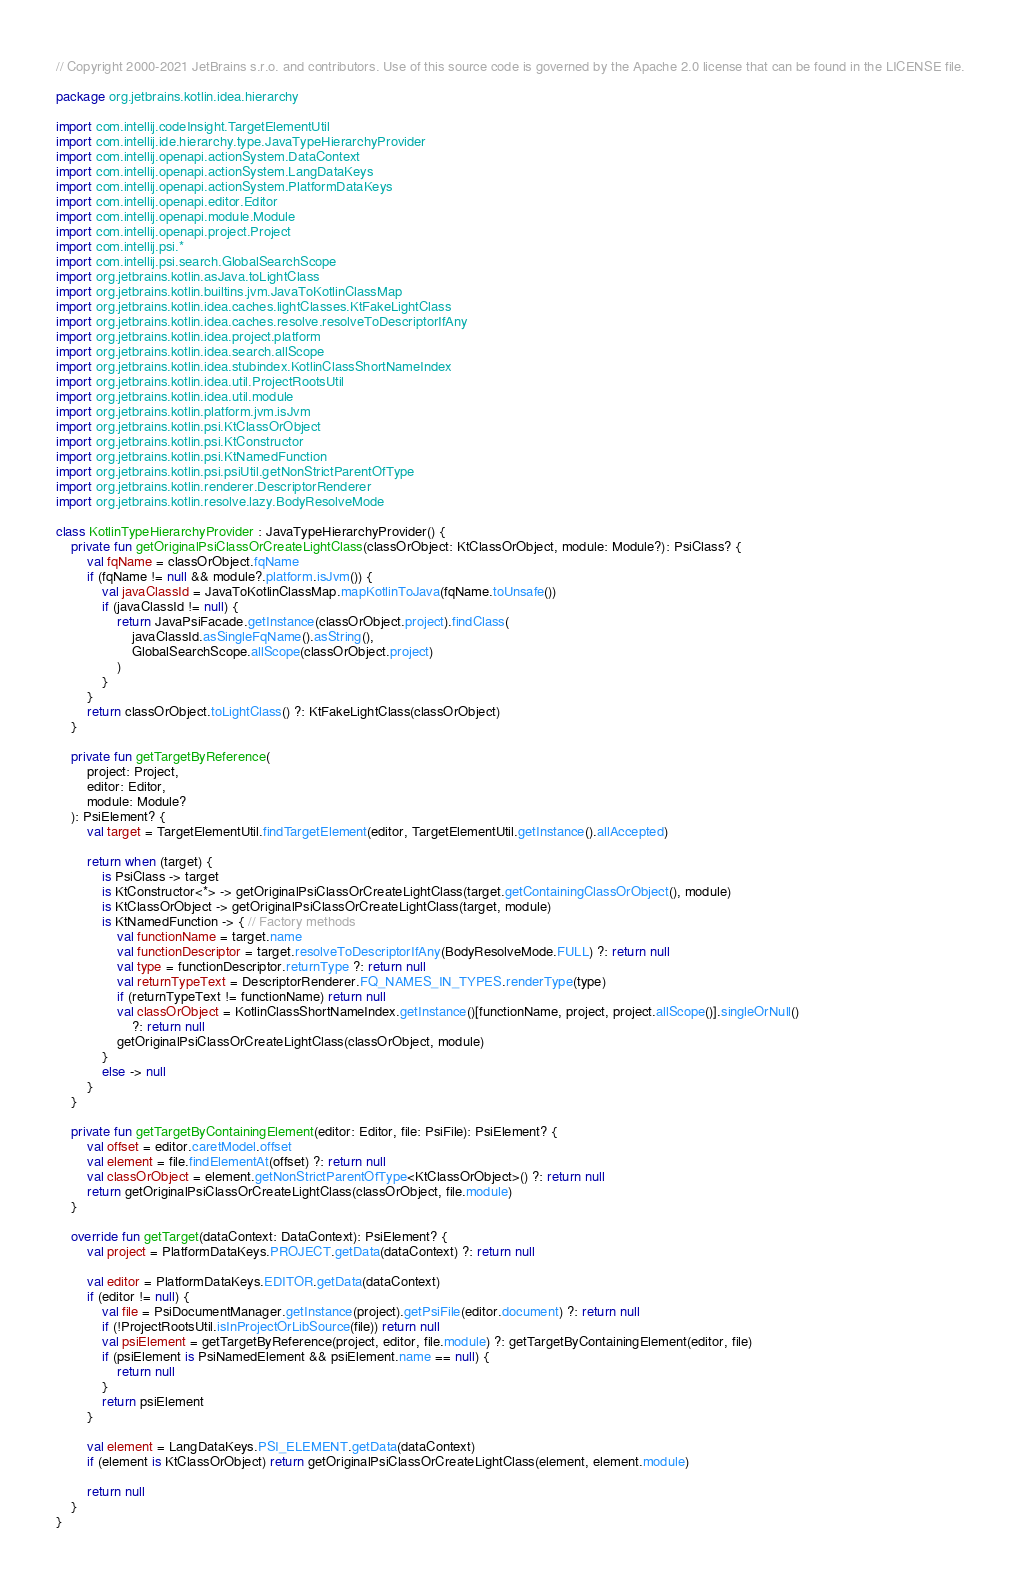<code> <loc_0><loc_0><loc_500><loc_500><_Kotlin_>// Copyright 2000-2021 JetBrains s.r.o. and contributors. Use of this source code is governed by the Apache 2.0 license that can be found in the LICENSE file.

package org.jetbrains.kotlin.idea.hierarchy

import com.intellij.codeInsight.TargetElementUtil
import com.intellij.ide.hierarchy.type.JavaTypeHierarchyProvider
import com.intellij.openapi.actionSystem.DataContext
import com.intellij.openapi.actionSystem.LangDataKeys
import com.intellij.openapi.actionSystem.PlatformDataKeys
import com.intellij.openapi.editor.Editor
import com.intellij.openapi.module.Module
import com.intellij.openapi.project.Project
import com.intellij.psi.*
import com.intellij.psi.search.GlobalSearchScope
import org.jetbrains.kotlin.asJava.toLightClass
import org.jetbrains.kotlin.builtins.jvm.JavaToKotlinClassMap
import org.jetbrains.kotlin.idea.caches.lightClasses.KtFakeLightClass
import org.jetbrains.kotlin.idea.caches.resolve.resolveToDescriptorIfAny
import org.jetbrains.kotlin.idea.project.platform
import org.jetbrains.kotlin.idea.search.allScope
import org.jetbrains.kotlin.idea.stubindex.KotlinClassShortNameIndex
import org.jetbrains.kotlin.idea.util.ProjectRootsUtil
import org.jetbrains.kotlin.idea.util.module
import org.jetbrains.kotlin.platform.jvm.isJvm
import org.jetbrains.kotlin.psi.KtClassOrObject
import org.jetbrains.kotlin.psi.KtConstructor
import org.jetbrains.kotlin.psi.KtNamedFunction
import org.jetbrains.kotlin.psi.psiUtil.getNonStrictParentOfType
import org.jetbrains.kotlin.renderer.DescriptorRenderer
import org.jetbrains.kotlin.resolve.lazy.BodyResolveMode

class KotlinTypeHierarchyProvider : JavaTypeHierarchyProvider() {
    private fun getOriginalPsiClassOrCreateLightClass(classOrObject: KtClassOrObject, module: Module?): PsiClass? {
        val fqName = classOrObject.fqName
        if (fqName != null && module?.platform.isJvm()) {
            val javaClassId = JavaToKotlinClassMap.mapKotlinToJava(fqName.toUnsafe())
            if (javaClassId != null) {
                return JavaPsiFacade.getInstance(classOrObject.project).findClass(
                    javaClassId.asSingleFqName().asString(),
                    GlobalSearchScope.allScope(classOrObject.project)
                )
            }
        }
        return classOrObject.toLightClass() ?: KtFakeLightClass(classOrObject)
    }

    private fun getTargetByReference(
        project: Project,
        editor: Editor,
        module: Module?
    ): PsiElement? {
        val target = TargetElementUtil.findTargetElement(editor, TargetElementUtil.getInstance().allAccepted)

        return when (target) {
            is PsiClass -> target
            is KtConstructor<*> -> getOriginalPsiClassOrCreateLightClass(target.getContainingClassOrObject(), module)
            is KtClassOrObject -> getOriginalPsiClassOrCreateLightClass(target, module)
            is KtNamedFunction -> { // Factory methods
                val functionName = target.name
                val functionDescriptor = target.resolveToDescriptorIfAny(BodyResolveMode.FULL) ?: return null
                val type = functionDescriptor.returnType ?: return null
                val returnTypeText = DescriptorRenderer.FQ_NAMES_IN_TYPES.renderType(type)
                if (returnTypeText != functionName) return null
                val classOrObject = KotlinClassShortNameIndex.getInstance()[functionName, project, project.allScope()].singleOrNull()
                    ?: return null
                getOriginalPsiClassOrCreateLightClass(classOrObject, module)
            }
            else -> null
        }
    }

    private fun getTargetByContainingElement(editor: Editor, file: PsiFile): PsiElement? {
        val offset = editor.caretModel.offset
        val element = file.findElementAt(offset) ?: return null
        val classOrObject = element.getNonStrictParentOfType<KtClassOrObject>() ?: return null
        return getOriginalPsiClassOrCreateLightClass(classOrObject, file.module)
    }

    override fun getTarget(dataContext: DataContext): PsiElement? {
        val project = PlatformDataKeys.PROJECT.getData(dataContext) ?: return null

        val editor = PlatformDataKeys.EDITOR.getData(dataContext)
        if (editor != null) {
            val file = PsiDocumentManager.getInstance(project).getPsiFile(editor.document) ?: return null
            if (!ProjectRootsUtil.isInProjectOrLibSource(file)) return null
            val psiElement = getTargetByReference(project, editor, file.module) ?: getTargetByContainingElement(editor, file)
            if (psiElement is PsiNamedElement && psiElement.name == null) {
                return null
            }
            return psiElement
        }

        val element = LangDataKeys.PSI_ELEMENT.getData(dataContext)
        if (element is KtClassOrObject) return getOriginalPsiClassOrCreateLightClass(element, element.module)

        return null
    }
}

</code> 